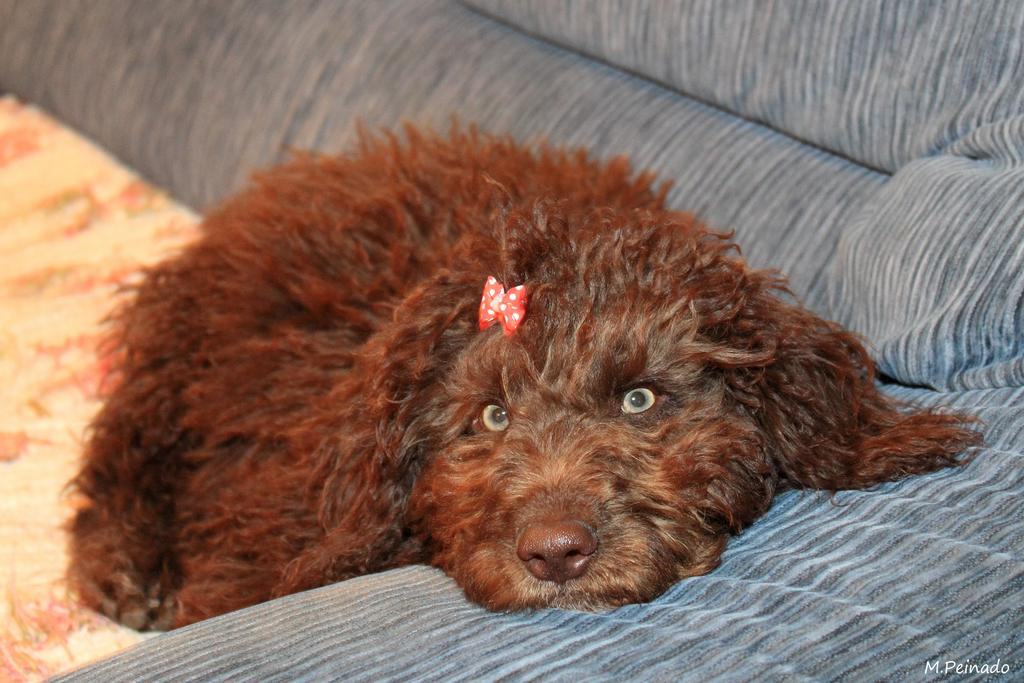What type of animal is in the image? There is a dog in the image. What is the dog doing in the image? The dog is lying on a sofa. What color is the dog in the image? The dog is brown in color. What color is the sofa the dog is lying on? The sofa is grey in color. What type of marble is visible on the floor in the image? There is no marble visible on the floor in the image; the focus is on the dog and the sofa. 